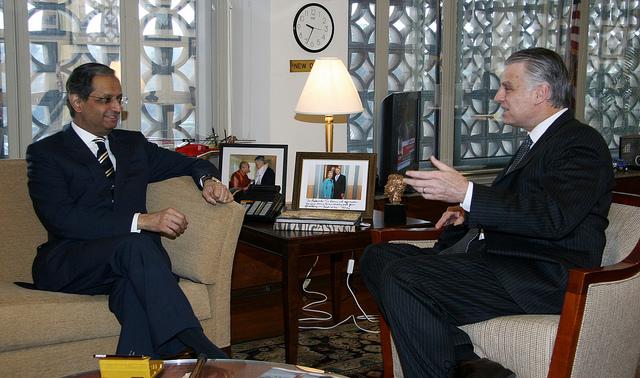Are these people dressed casually?
Write a very short answer. No. Are these two men making a deal?
Keep it brief. Yes. Is this a formal state visit?
Answer briefly. Yes. Where is the clock?
Keep it brief. On wall. 